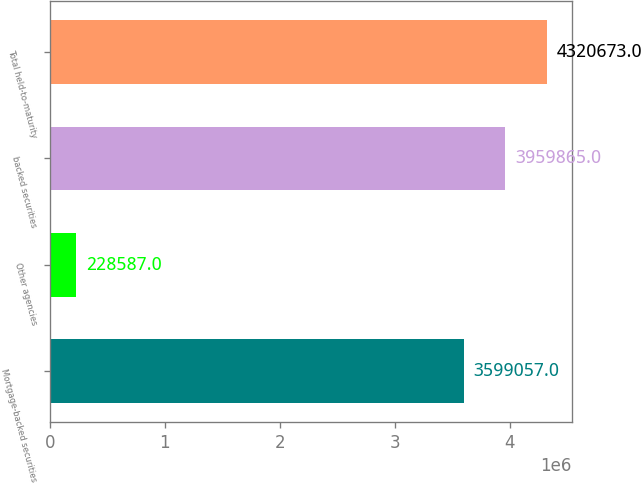<chart> <loc_0><loc_0><loc_500><loc_500><bar_chart><fcel>Mortgage-backed securities<fcel>Other agencies<fcel>backed securities<fcel>Total held-to-maturity<nl><fcel>3.59906e+06<fcel>228587<fcel>3.95986e+06<fcel>4.32067e+06<nl></chart> 